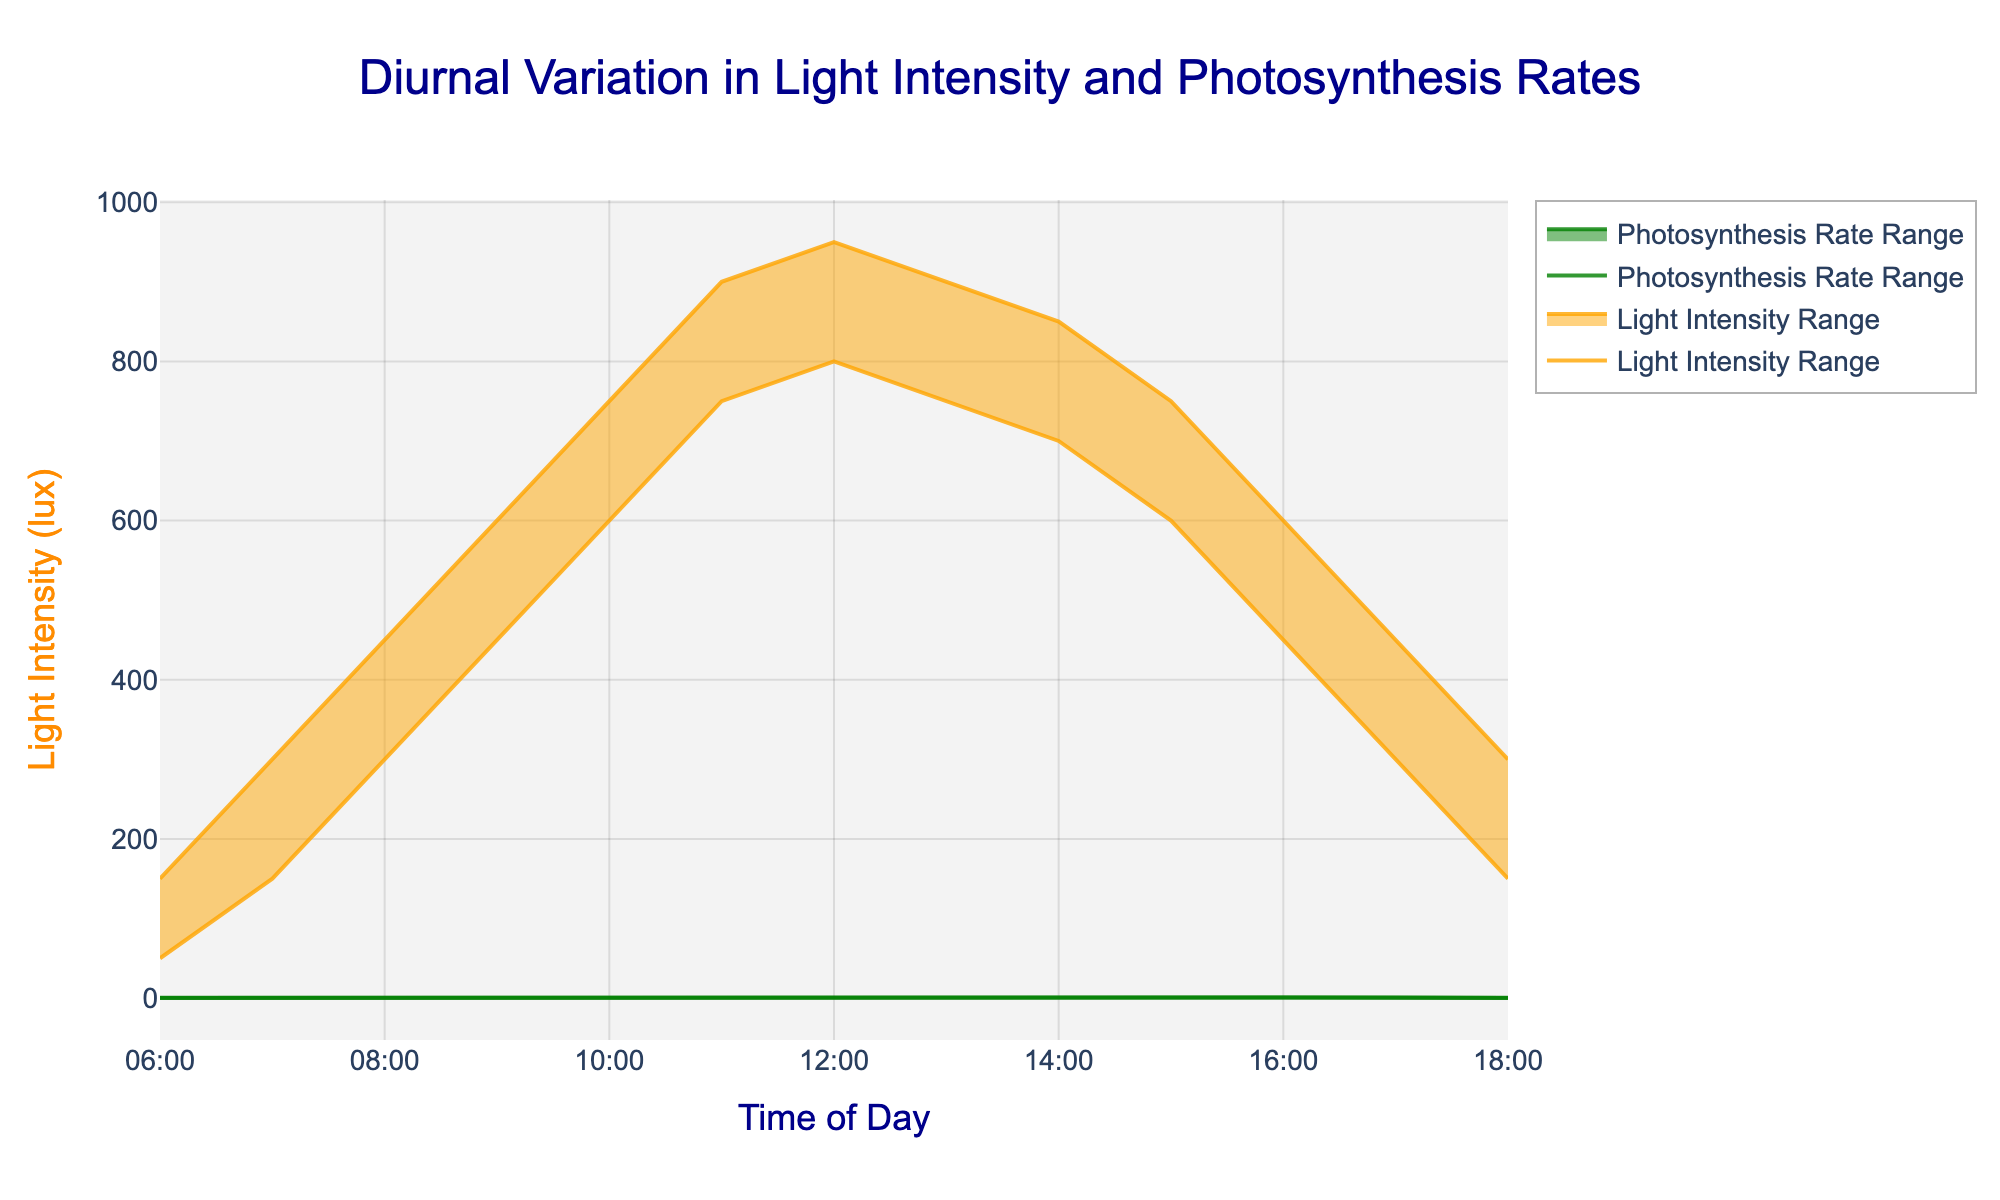What is the title of the figure? The title of the figure is typically found at the top center of the plot, providing an overview of what the chart represents. In this case, the title is specified in the code.
Answer: Diurnal Variation in Light Intensity and Photosynthesis Rates What do the x-axis and y-axis represent? The x-axis, labeled "Time of Day," shows the time frame from 06:00 to 18:00. The primary y-axis on the left is for "Light Intensity (lux)" and the secondary y-axis on the right is for "Photosynthesis Rate (μmol CO₂/m²/s)."
Answer: Time of Day, Light Intensity (lux), Photosynthesis Rate (μmol CO₂/m²/s) How does light intensity change throughout the day? To find this, we observe the range area for light intensity, which increases from 50-150 lux at 06:00 to a peak of 800-950 lux by 12:00, then gradually decreases back to 150-300 lux by 18:00.
Answer: Increasing till 12:00, then decreasing At what time does the photosynthesis rate reach its maximum range? By examining the photosynthesis rate range area, the maximum rate occurs between 12:00 and 13:00, where the rate is between 1.2 and 1.5 μmol CO₂/m²/s.
Answer: 12:00-13:00 What is the range of light intensity at 10:00? The range can be found by looking at the light intensity range area at 10:00, which is from 600 to 750 lux.
Answer: 600-750 lux Compare the photosynthesis rates between 08:00 and 16:00. At 08:00, the photosynthesis rate ranges from 0.5 to 0.7 μmol CO₂/m²/s. At 16:00, it ranges from 0.6 to 0.8 μmol CO₂/m²/s. Observing these differences, the rate at 16:00 is slightly higher.
Answer: The rate at 16:00 is slightly higher How does the light intensity at 06:00 compare to that at 12:00? At 06:00, the light intensity ranges from 50 to 150 lux, whereas at 12:00, it ranges from 800 to 950 lux. Hence, the light intensity at 12:00 is significantly higher.
Answer: Light intensity at 12:00 is higher During which time period is the photosynthesis rate the lowest? By examining the range areas, the lowest photosynthesis rate is between 06:00 and 07:00, with values ranging from 0.1 to 0.3 μmol CO₂/m²/s.
Answer: 06:00-07:00 What is the duration of the peak light intensity? The peak light intensity occurs at 12:00 with 800-950 lux and slightly reduces around 13:00 with 750-900 lux. The peak duration is therefore around these two hours.
Answer: Approximately 2 hours Is there a correlation between light intensity and photosynthesis rate? Observing the trend lines, as light intensity increases from morning to noon, the photosynthesis rate also increases, suggesting a positive correlation. In the afternoon, as the light intensity decreases, so does the photosynthesis rate, further supporting this relationship.
Answer: Positive correlation 